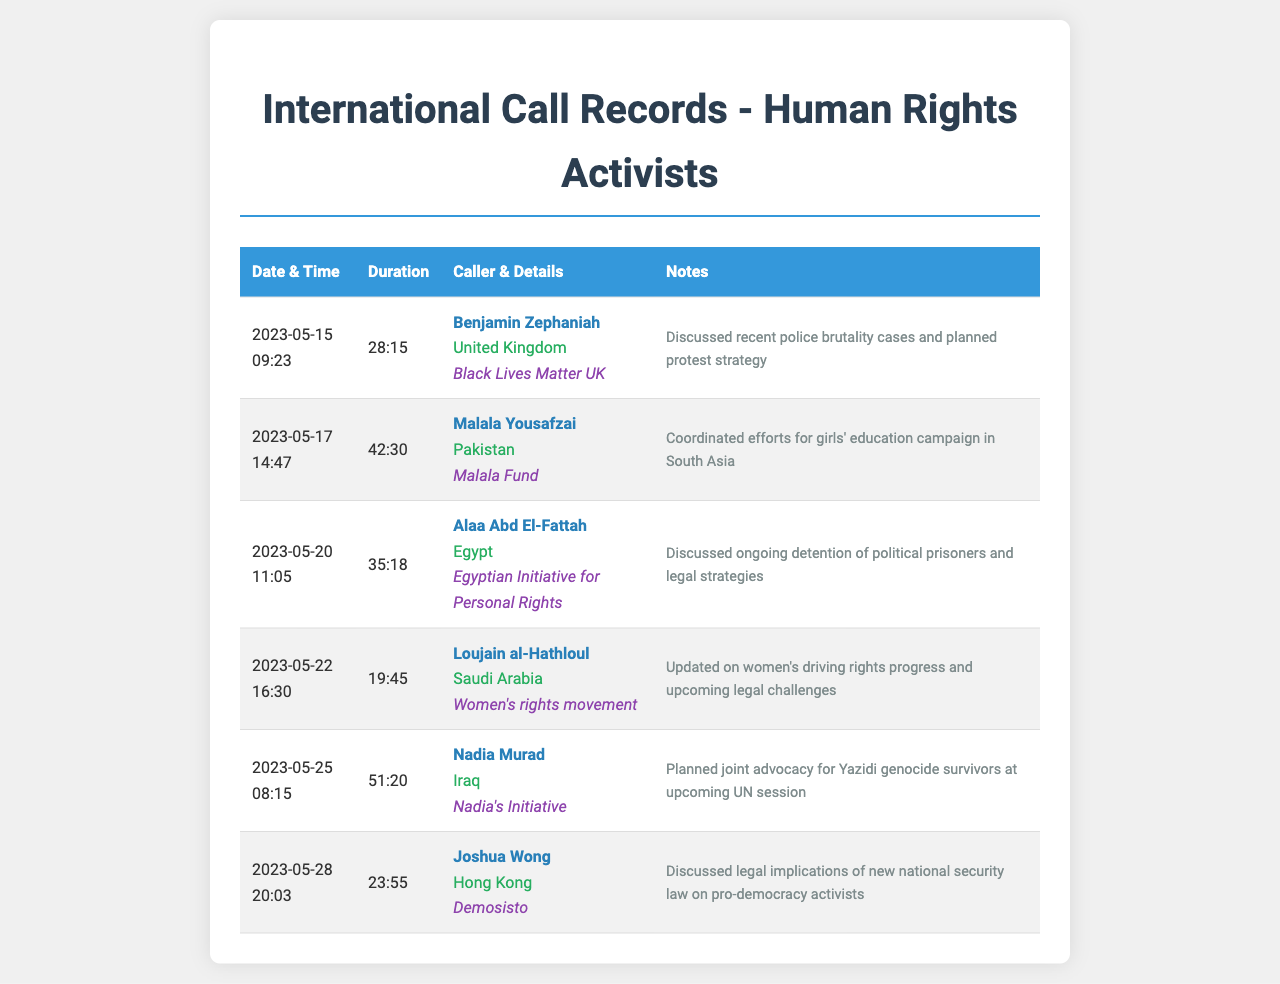What date was the call with Benjamin Zephaniah? The call with Benjamin Zephaniah took place on May 15, 2023.
Answer: May 15, 2023 How long was the call with Malala Yousafzai? The duration of the call with Malala Yousafzai was 42 minutes and 30 seconds.
Answer: 42:30 Which organization is associated with Loujain al-Hathloul? The organization associated with Loujain al-Hathloul is the Women's rights movement.
Answer: Women's rights movement What was discussed during the call with Nadia Murad? The discussion during the call with Nadia Murad focused on planning joint advocacy for Yazidi genocide survivors.
Answer: Planned joint advocacy for Yazidi genocide survivors Who called from Hong Kong on May 28, 2023? The caller from Hong Kong on May 28, 2023, was Joshua Wong.
Answer: Joshua Wong What is the common theme among the calls listed? The common theme is discussing human rights issues and advocacy efforts across various countries.
Answer: Human rights issues How many total calls are recorded in the document? There are a total of six calls recorded in the document.
Answer: Six Which caller discussed police brutality during their call? The caller who discussed police brutality was Benjamin Zephaniah.
Answer: Benjamin Zephaniah What legal issue was addressed in the conversation with Joshua Wong? The legal issue discussed with Joshua Wong was the implications of the new national security law.
Answer: New national security law 